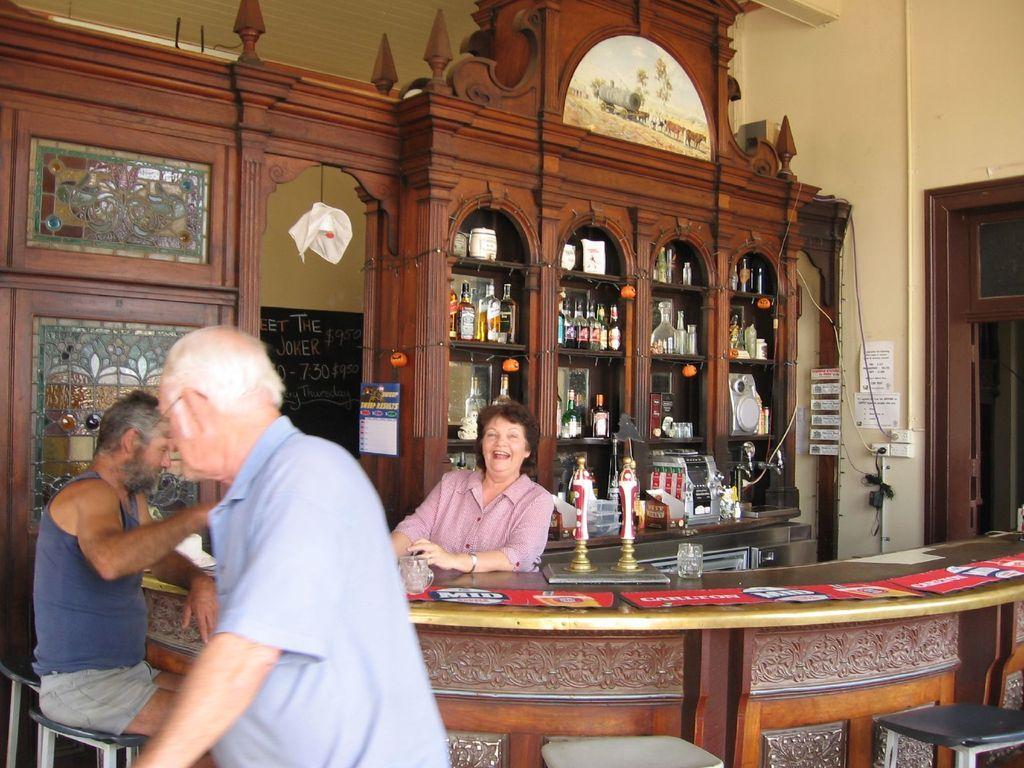Describe this image in one or two sentences. In this image I can see three people with different color dresses. In-front of these people I can see the table and there are some papers and glass on it. In the back I can see the wine rack and the papers to the wall. 